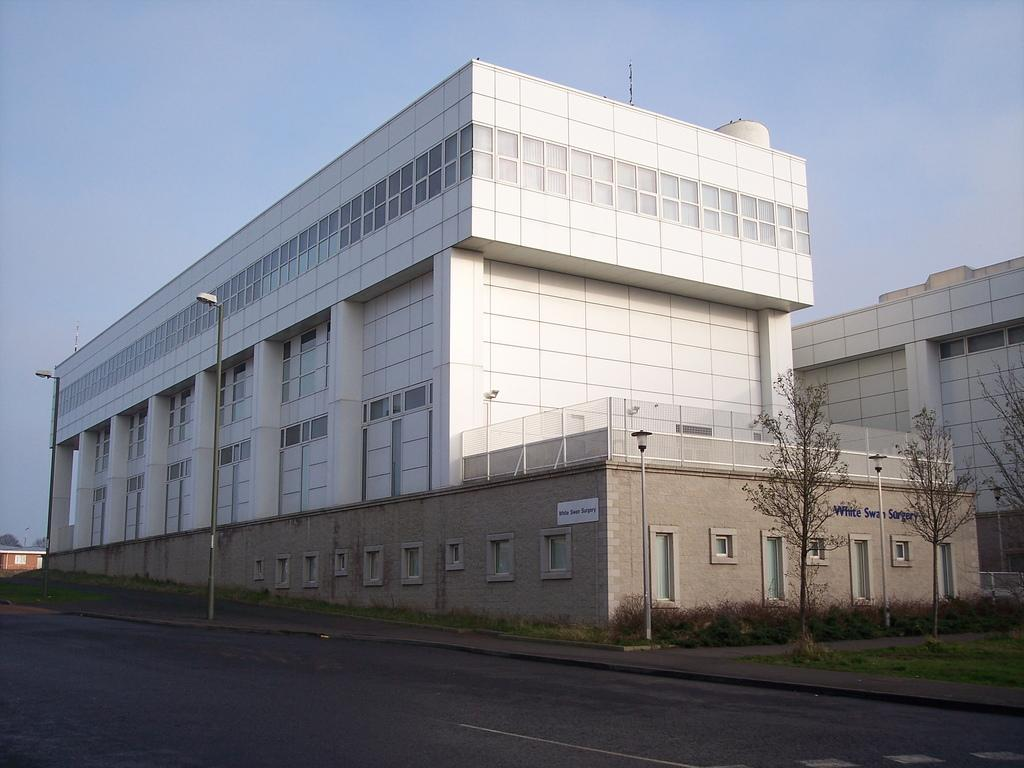What is the main feature of the image? There is a road in the image. What can be seen near the road? There are many trees near the road. What else is visible in the image? There are poles and buildings with windows in the image. What is visible in the background of the image? The sky is visible in the background of the image. What type of pail is being used in the war depicted in the image? There is no war or pail present in the image. How many hands are visible in the image? There is no reference to hands in the image, so it is not possible to determine how many hands are visible. 